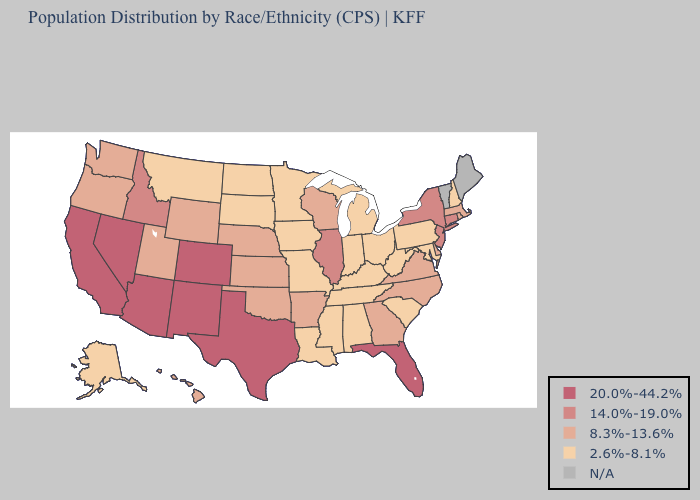Is the legend a continuous bar?
Keep it brief. No. Name the states that have a value in the range 8.3%-13.6%?
Keep it brief. Arkansas, Delaware, Georgia, Hawaii, Kansas, Massachusetts, Nebraska, North Carolina, Oklahoma, Oregon, Rhode Island, Utah, Virginia, Washington, Wisconsin, Wyoming. What is the value of Oregon?
Be succinct. 8.3%-13.6%. What is the lowest value in states that border Arkansas?
Give a very brief answer. 2.6%-8.1%. What is the value of Washington?
Answer briefly. 8.3%-13.6%. Does Pennsylvania have the lowest value in the Northeast?
Answer briefly. Yes. Name the states that have a value in the range 2.6%-8.1%?
Concise answer only. Alabama, Alaska, Indiana, Iowa, Kentucky, Louisiana, Maryland, Michigan, Minnesota, Mississippi, Missouri, Montana, New Hampshire, North Dakota, Ohio, Pennsylvania, South Carolina, South Dakota, Tennessee, West Virginia. What is the highest value in the USA?
Be succinct. 20.0%-44.2%. How many symbols are there in the legend?
Keep it brief. 5. What is the value of Alaska?
Give a very brief answer. 2.6%-8.1%. Does Wyoming have the highest value in the USA?
Give a very brief answer. No. What is the highest value in states that border Nevada?
Concise answer only. 20.0%-44.2%. Name the states that have a value in the range 8.3%-13.6%?
Be succinct. Arkansas, Delaware, Georgia, Hawaii, Kansas, Massachusetts, Nebraska, North Carolina, Oklahoma, Oregon, Rhode Island, Utah, Virginia, Washington, Wisconsin, Wyoming. What is the value of Rhode Island?
Write a very short answer. 8.3%-13.6%. 